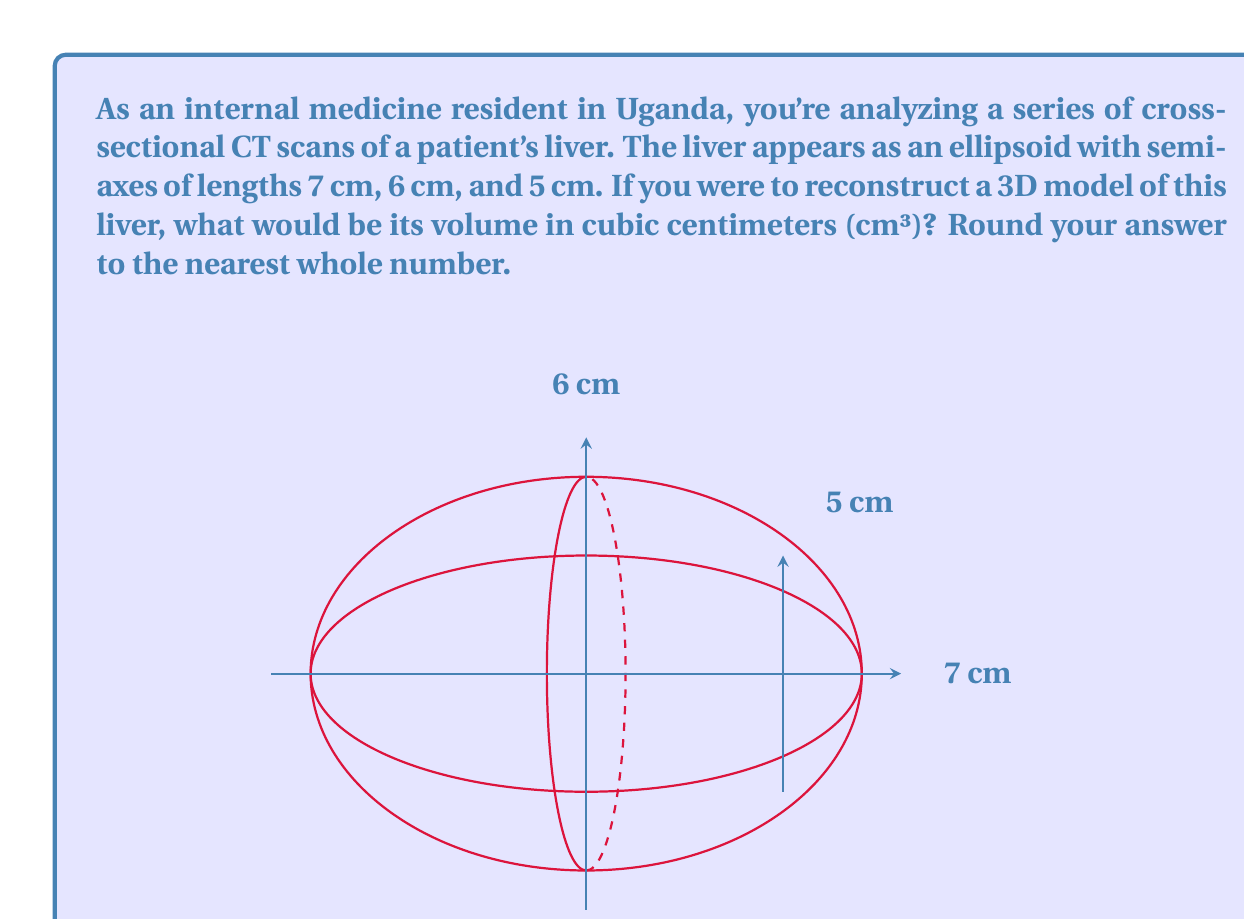Give your solution to this math problem. To solve this problem, we'll follow these steps:

1) The volume of an ellipsoid is given by the formula:

   $$V = \frac{4}{3}\pi abc$$

   where $a$, $b$, and $c$ are the semi-axes lengths.

2) In this case, we have:
   $a = 7$ cm
   $b = 6$ cm
   $c = 5$ cm

3) Let's substitute these values into the formula:

   $$V = \frac{4}{3}\pi (7)(6)(5)$$

4) Simplify:
   $$V = \frac{4}{3}\pi (210)$$

5) Calculate:
   $$V = \frac{4}{3} (210\pi)$$
   $$V = 280\pi$$

6) Use $\pi \approx 3.14159$:
   $$V \approx 280 (3.14159)$$
   $$V \approx 879.6452$$

7) Rounding to the nearest whole number:
   $$V \approx 880$$ cm³

Therefore, the volume of the liver, based on the 3D reconstruction from CT scans, is approximately 880 cm³.
Answer: 880 cm³ 